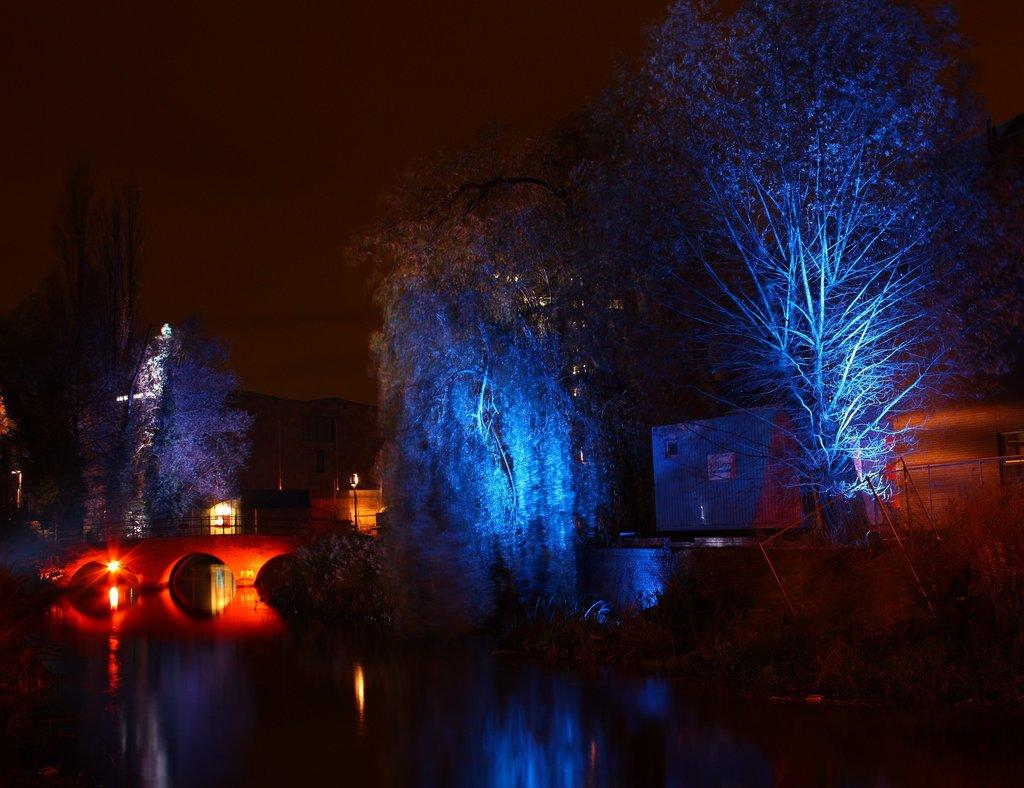What is the main feature of the image? There is water in the image. What is built over the water? There is a bridge over the water. What colors are the lights on the bridge? Red and blue color lights are present. What can be seen in the background of the image? There are trees and the sky visible in the background of the image. What type of pear is hanging from the bridge in the image? There is no pear present in the image; the lights on the bridge are red and blue. 